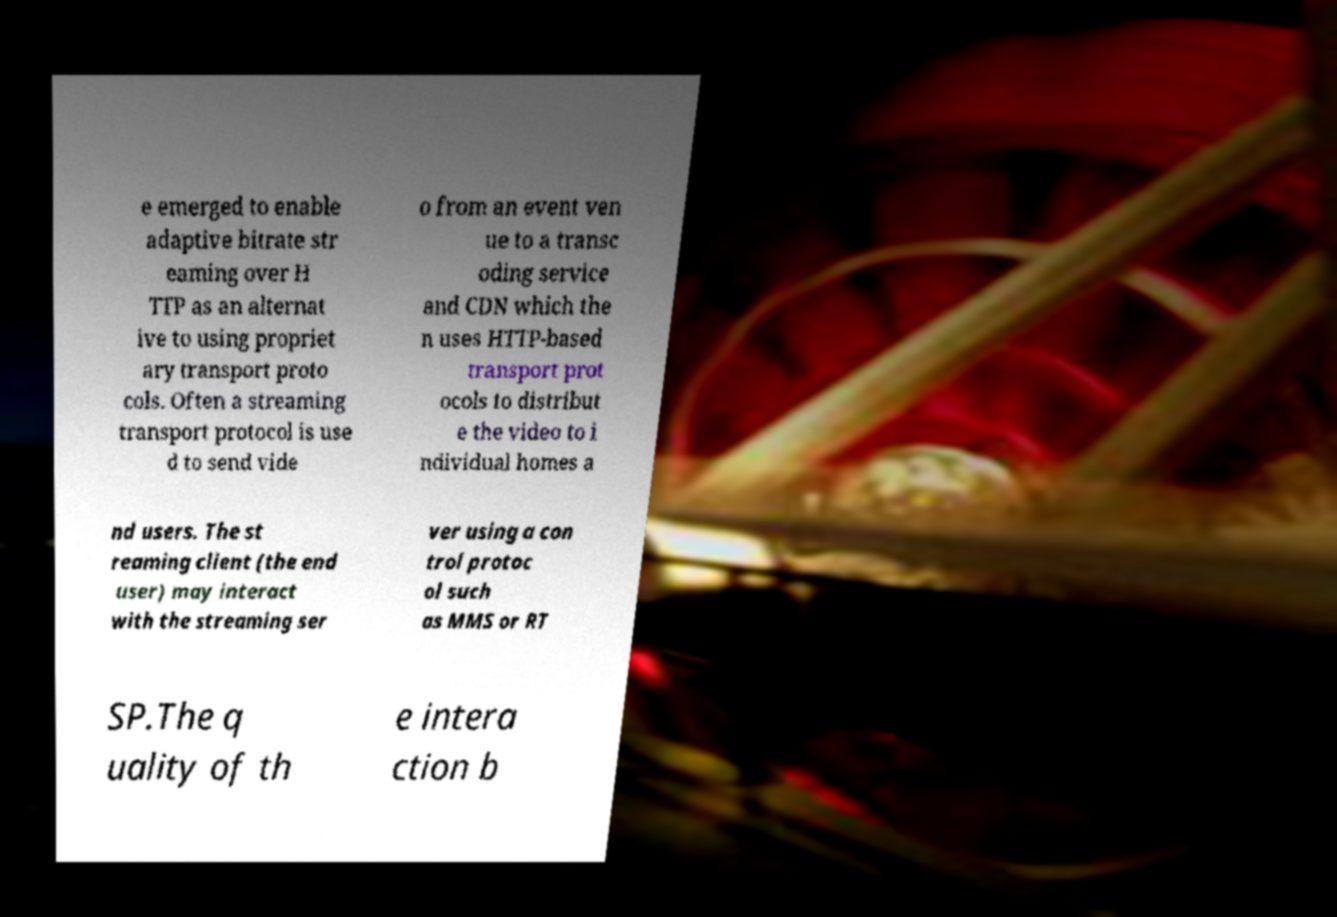Can you accurately transcribe the text from the provided image for me? e emerged to enable adaptive bitrate str eaming over H TTP as an alternat ive to using propriet ary transport proto cols. Often a streaming transport protocol is use d to send vide o from an event ven ue to a transc oding service and CDN which the n uses HTTP-based transport prot ocols to distribut e the video to i ndividual homes a nd users. The st reaming client (the end user) may interact with the streaming ser ver using a con trol protoc ol such as MMS or RT SP.The q uality of th e intera ction b 